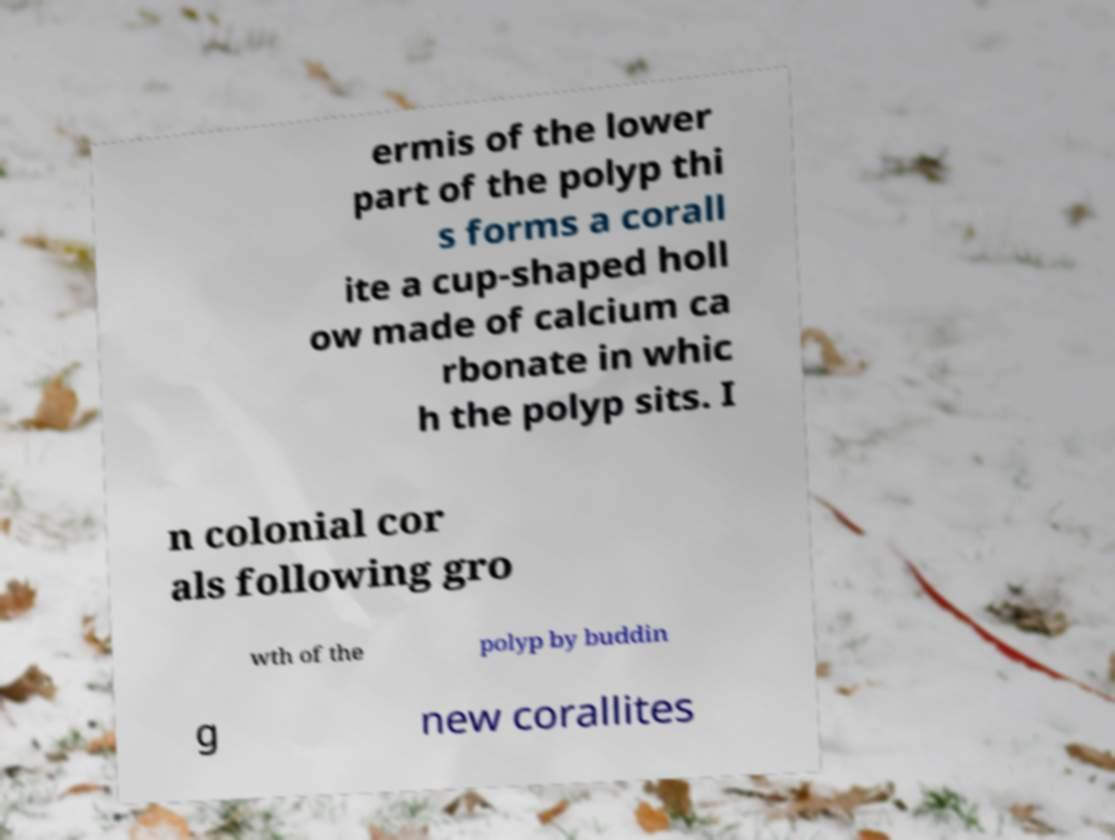Could you assist in decoding the text presented in this image and type it out clearly? ermis of the lower part of the polyp thi s forms a corall ite a cup-shaped holl ow made of calcium ca rbonate in whic h the polyp sits. I n colonial cor als following gro wth of the polyp by buddin g new corallites 